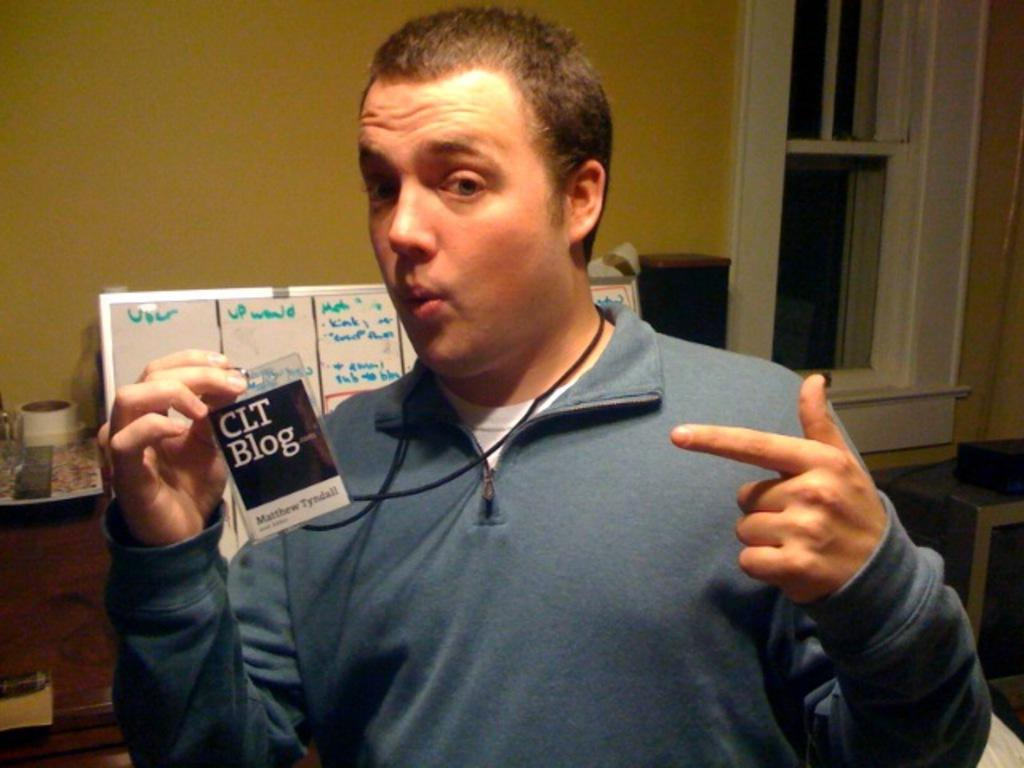What is the man in the image doing? The man is standing in the image and holding an I-card. What can be seen in the background of the image? There is a board and a wall in the background of the image. Where is the window located in the image? The window is on the right side of the image. What type of insect can be seen crawling on the man's I-card in the image? There is no insect present on the man's I-card in the image. How many pies are visible on the board in the background of the image? There are no pies visible on the board in the background of the image. 